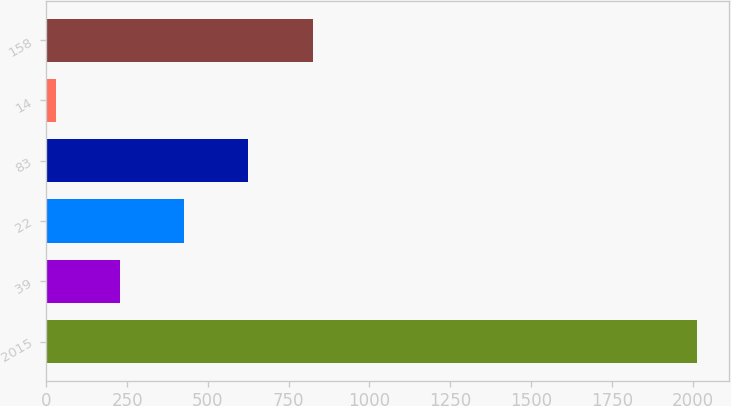Convert chart. <chart><loc_0><loc_0><loc_500><loc_500><bar_chart><fcel>2015<fcel>39<fcel>22<fcel>83<fcel>14<fcel>158<nl><fcel>2013<fcel>229.2<fcel>427.4<fcel>625.6<fcel>31<fcel>823.8<nl></chart> 